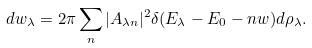<formula> <loc_0><loc_0><loc_500><loc_500>d w _ { \lambda } = 2 \pi \sum _ { n } | A _ { \lambda n } | ^ { 2 } \delta ( E _ { \lambda } - E _ { 0 } - n w ) d \rho _ { \lambda } .</formula> 